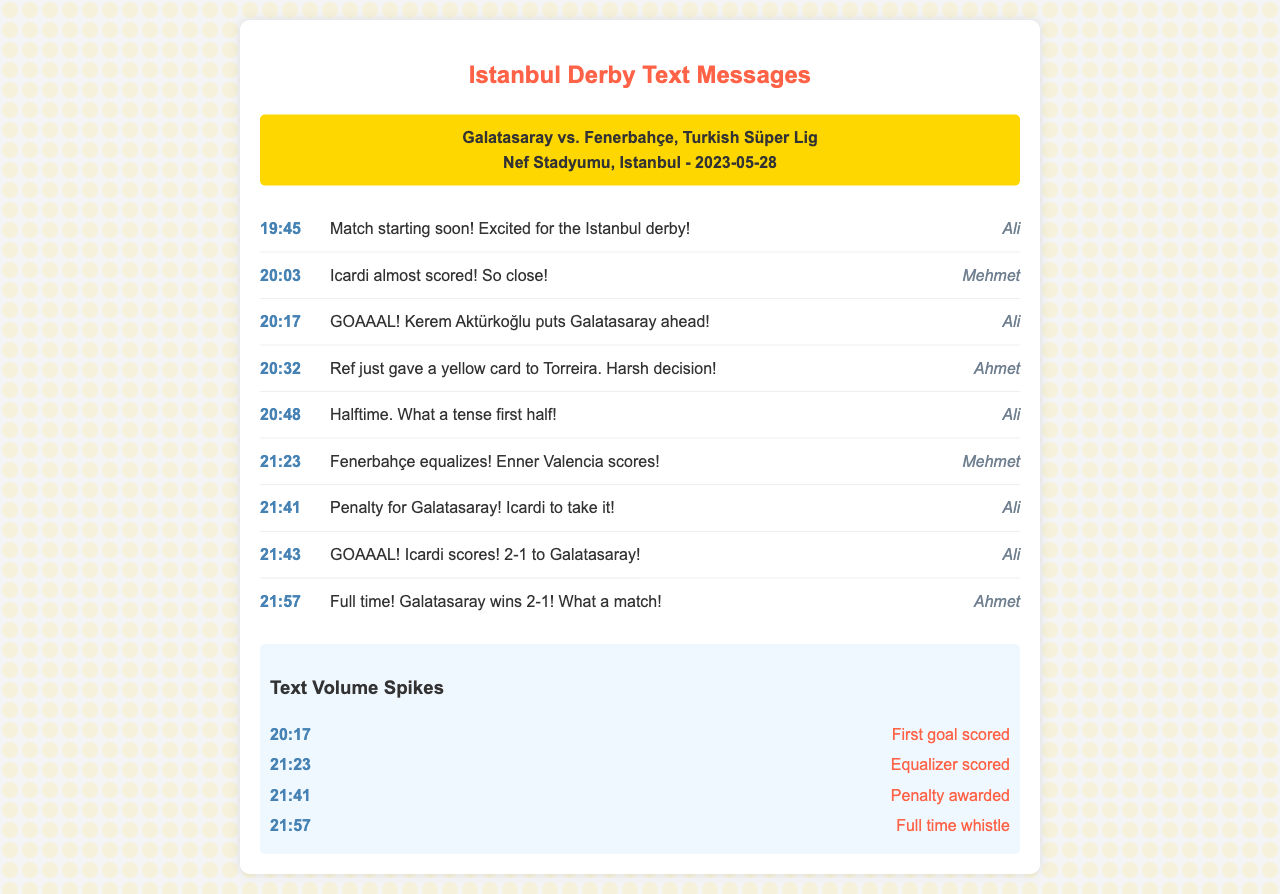What is the date of the match? The date of the match is specified in the document as 2023-05-28.
Answer: 2023-05-28 Who scored the first goal? The first goal is mentioned in the text, scored by Kerem Aktürkoğlu for Galatasaray.
Answer: Kerem Aktürkoğlu What time did the game reach halftime? The document shows that halftime was called at 20:48.
Answer: 20:48 How many goals did Icardi score in the match? The messages indicate that Icardi scored one goal for Galatasaray in the match.
Answer: 1 What event caused a text volume spike at 21:23? The document states that Fenerbahçe scored the equalizer, which caused the spike.
Answer: Equalizer scored What was the final score of the match? The messages indicate that Galatasaray won with a score of 2-1.
Answer: 2-1 What time was the penalty awarded? According to the text, the penalty for Galatasaray was awarded at 21:41.
Answer: 21:41 Who sent the message about the yellow card? The message regarding the yellow card issued to Torreira was sent by Ahmet.
Answer: Ahmet 